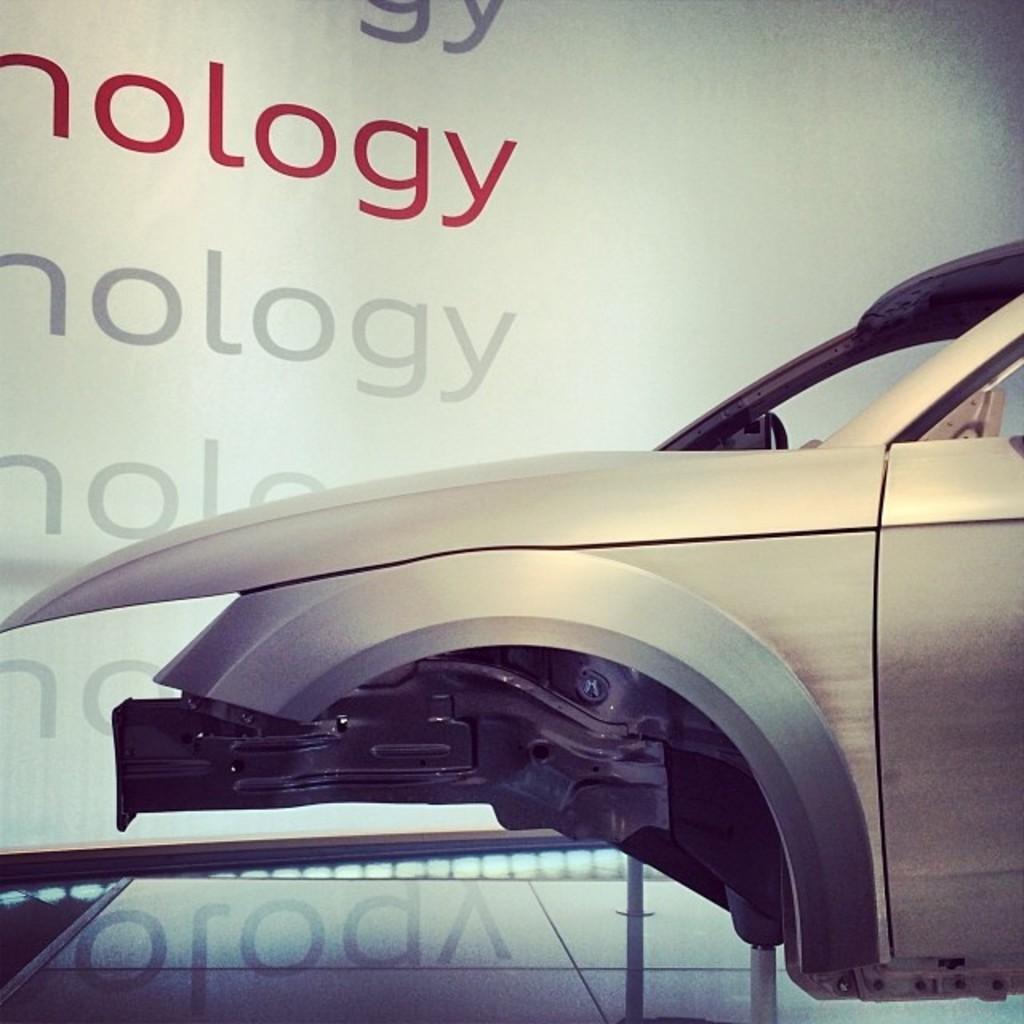Describe this image in one or two sentences. In this picture there is a vehicle. At the back there is text on the board. At the bottom it looks like a glass and there is reflection of text on the glass. 